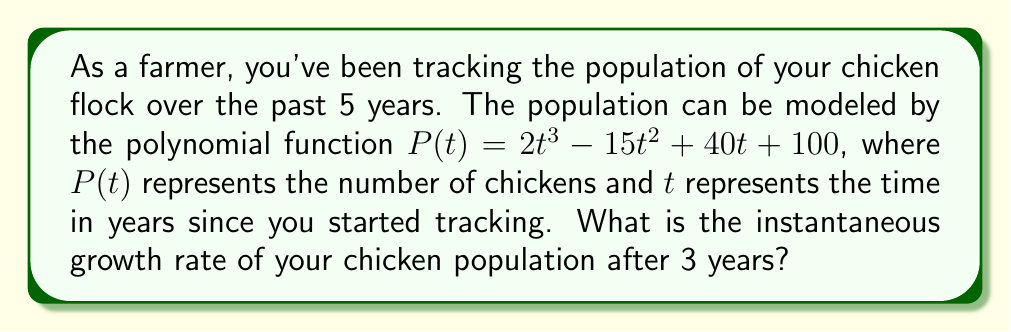Solve this math problem. To find the instantaneous growth rate after 3 years, we need to calculate the derivative of the polynomial function $P(t)$ and evaluate it at $t = 3$. Here's the step-by-step process:

1. Given polynomial function: $P(t) = 2t^3 - 15t^2 + 40t + 100$

2. Calculate the derivative $P'(t)$:
   $P'(t) = \frac{d}{dt}(2t^3 - 15t^2 + 40t + 100)$
   $P'(t) = 6t^2 - 30t + 40$

3. Evaluate $P'(t)$ at $t = 3$:
   $P'(3) = 6(3)^2 - 30(3) + 40$
   $P'(3) = 6(9) - 90 + 40$
   $P'(3) = 54 - 90 + 40$
   $P'(3) = 4$

The instantaneous growth rate is the value of the derivative at the given point. Therefore, the growth rate after 3 years is 4 chickens per year.
Answer: 4 chickens per year 